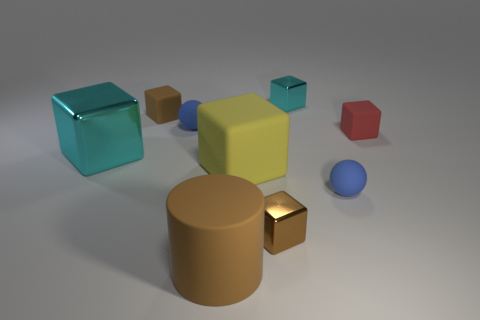Can you describe the colors of the objects in the image? Certainly! The image features objects in a variety of colors. There's a large cyan cube, a yellow cube of medium size, and a smaller brown cube. We also see a golden cylinder, a small, shiny, golden rectangle, a small red hexagon, and a small blue sphere. Each object has a distinct, solid color with a matte or slightly reflective finish. 